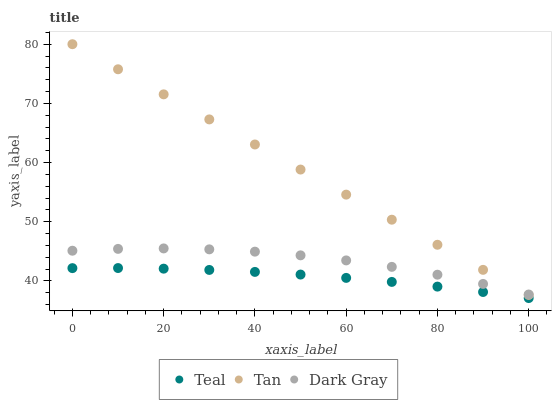Does Teal have the minimum area under the curve?
Answer yes or no. Yes. Does Tan have the maximum area under the curve?
Answer yes or no. Yes. Does Tan have the minimum area under the curve?
Answer yes or no. No. Does Teal have the maximum area under the curve?
Answer yes or no. No. Is Tan the smoothest?
Answer yes or no. Yes. Is Dark Gray the roughest?
Answer yes or no. Yes. Is Teal the smoothest?
Answer yes or no. No. Is Teal the roughest?
Answer yes or no. No. Does Teal have the lowest value?
Answer yes or no. Yes. Does Tan have the lowest value?
Answer yes or no. No. Does Tan have the highest value?
Answer yes or no. Yes. Does Teal have the highest value?
Answer yes or no. No. Is Teal less than Tan?
Answer yes or no. Yes. Is Dark Gray greater than Teal?
Answer yes or no. Yes. Does Dark Gray intersect Tan?
Answer yes or no. Yes. Is Dark Gray less than Tan?
Answer yes or no. No. Is Dark Gray greater than Tan?
Answer yes or no. No. Does Teal intersect Tan?
Answer yes or no. No. 